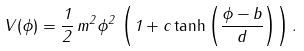<formula> <loc_0><loc_0><loc_500><loc_500>V ( \phi ) = \frac { 1 } { 2 } \, m ^ { 2 } \phi ^ { 2 } \, \left ( 1 + c \tanh \left ( \frac { \phi - b } { d } \right ) \right ) .</formula> 